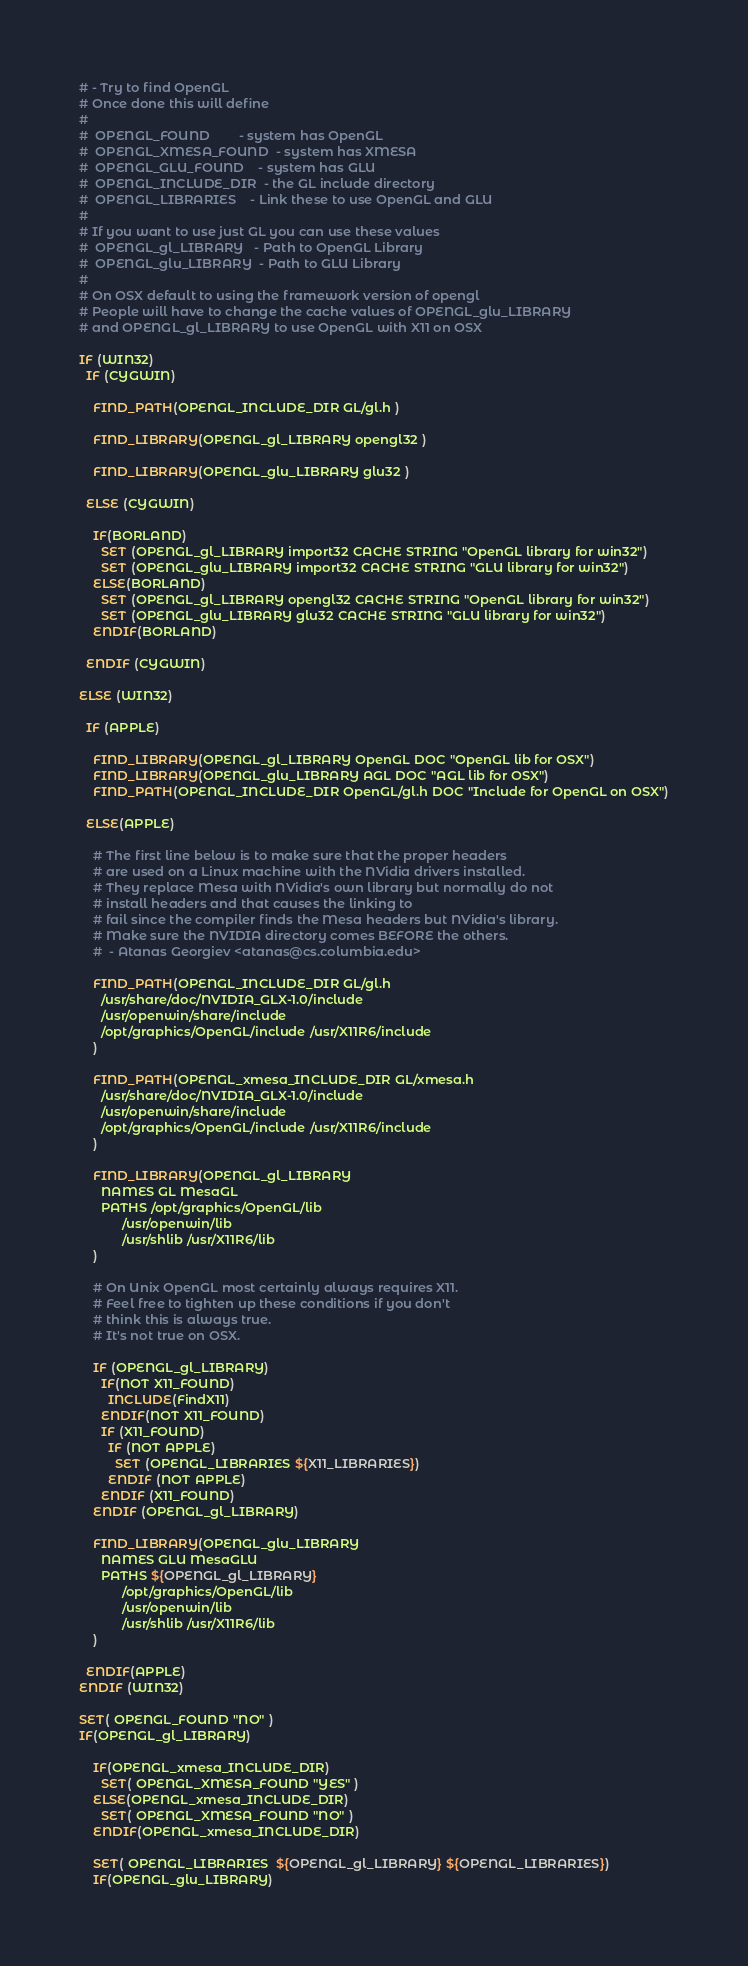Convert code to text. <code><loc_0><loc_0><loc_500><loc_500><_CMake_># - Try to find OpenGL
# Once done this will define
#  
#  OPENGL_FOUND        - system has OpenGL
#  OPENGL_XMESA_FOUND  - system has XMESA
#  OPENGL_GLU_FOUND    - system has GLU
#  OPENGL_INCLUDE_DIR  - the GL include directory
#  OPENGL_LIBRARIES    - Link these to use OpenGL and GLU
#   
# If you want to use just GL you can use these values
#  OPENGL_gl_LIBRARY   - Path to OpenGL Library
#  OPENGL_glu_LIBRARY  - Path to GLU Library
#  
# On OSX default to using the framework version of opengl
# People will have to change the cache values of OPENGL_glu_LIBRARY 
# and OPENGL_gl_LIBRARY to use OpenGL with X11 on OSX

IF (WIN32)
  IF (CYGWIN)

    FIND_PATH(OPENGL_INCLUDE_DIR GL/gl.h )

    FIND_LIBRARY(OPENGL_gl_LIBRARY opengl32 )

    FIND_LIBRARY(OPENGL_glu_LIBRARY glu32 )

  ELSE (CYGWIN)

    IF(BORLAND)
      SET (OPENGL_gl_LIBRARY import32 CACHE STRING "OpenGL library for win32")
      SET (OPENGL_glu_LIBRARY import32 CACHE STRING "GLU library for win32")
    ELSE(BORLAND)
      SET (OPENGL_gl_LIBRARY opengl32 CACHE STRING "OpenGL library for win32")
      SET (OPENGL_glu_LIBRARY glu32 CACHE STRING "GLU library for win32")
    ENDIF(BORLAND)

  ENDIF (CYGWIN)

ELSE (WIN32)

  IF (APPLE)

    FIND_LIBRARY(OPENGL_gl_LIBRARY OpenGL DOC "OpenGL lib for OSX")
    FIND_LIBRARY(OPENGL_glu_LIBRARY AGL DOC "AGL lib for OSX")
    FIND_PATH(OPENGL_INCLUDE_DIR OpenGL/gl.h DOC "Include for OpenGL on OSX")

  ELSE(APPLE)

    # The first line below is to make sure that the proper headers
    # are used on a Linux machine with the NVidia drivers installed.
    # They replace Mesa with NVidia's own library but normally do not
    # install headers and that causes the linking to
    # fail since the compiler finds the Mesa headers but NVidia's library.
    # Make sure the NVIDIA directory comes BEFORE the others.
    #  - Atanas Georgiev <atanas@cs.columbia.edu>

    FIND_PATH(OPENGL_INCLUDE_DIR GL/gl.h
      /usr/share/doc/NVIDIA_GLX-1.0/include
      /usr/openwin/share/include
      /opt/graphics/OpenGL/include /usr/X11R6/include
    )

    FIND_PATH(OPENGL_xmesa_INCLUDE_DIR GL/xmesa.h
      /usr/share/doc/NVIDIA_GLX-1.0/include
      /usr/openwin/share/include
      /opt/graphics/OpenGL/include /usr/X11R6/include
    )

    FIND_LIBRARY(OPENGL_gl_LIBRARY
      NAMES GL MesaGL
      PATHS /opt/graphics/OpenGL/lib
            /usr/openwin/lib
            /usr/shlib /usr/X11R6/lib
    )

    # On Unix OpenGL most certainly always requires X11.
    # Feel free to tighten up these conditions if you don't 
    # think this is always true.
    # It's not true on OSX.

    IF (OPENGL_gl_LIBRARY)
      IF(NOT X11_FOUND)
        INCLUDE(FindX11)
      ENDIF(NOT X11_FOUND)
      IF (X11_FOUND)
        IF (NOT APPLE)
          SET (OPENGL_LIBRARIES ${X11_LIBRARIES})
        ENDIF (NOT APPLE)
      ENDIF (X11_FOUND)
    ENDIF (OPENGL_gl_LIBRARY)

    FIND_LIBRARY(OPENGL_glu_LIBRARY
      NAMES GLU MesaGLU
      PATHS ${OPENGL_gl_LIBRARY}
            /opt/graphics/OpenGL/lib
            /usr/openwin/lib
            /usr/shlib /usr/X11R6/lib
    )

  ENDIF(APPLE)
ENDIF (WIN32)

SET( OPENGL_FOUND "NO" )
IF(OPENGL_gl_LIBRARY)

    IF(OPENGL_xmesa_INCLUDE_DIR)
      SET( OPENGL_XMESA_FOUND "YES" )
    ELSE(OPENGL_xmesa_INCLUDE_DIR)
      SET( OPENGL_XMESA_FOUND "NO" )
    ENDIF(OPENGL_xmesa_INCLUDE_DIR)

    SET( OPENGL_LIBRARIES  ${OPENGL_gl_LIBRARY} ${OPENGL_LIBRARIES})
    IF(OPENGL_glu_LIBRARY)</code> 